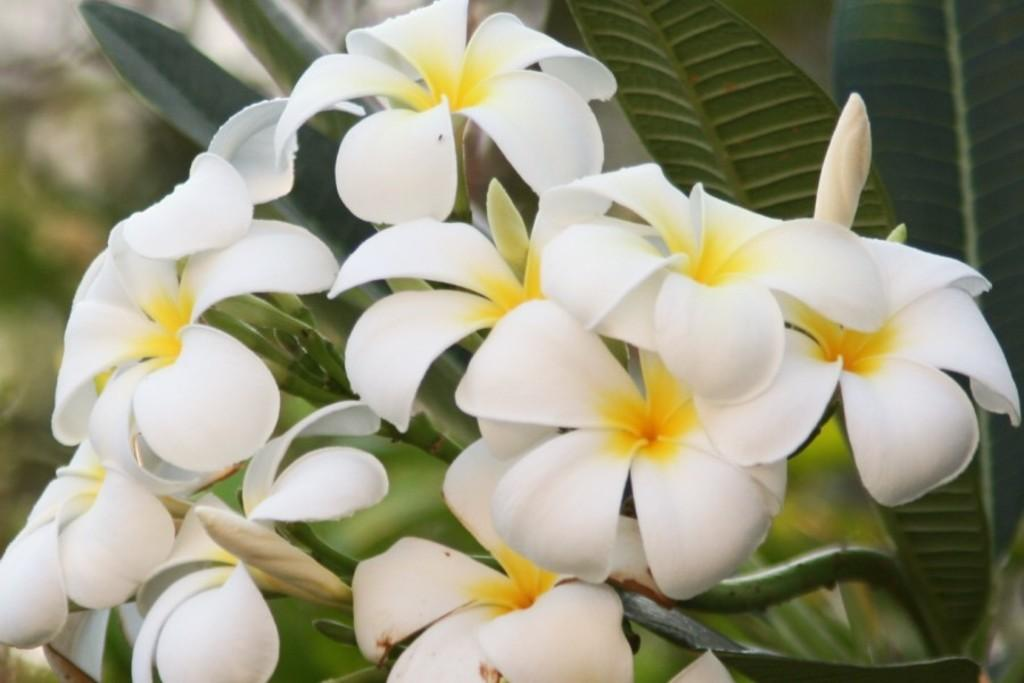What type of living organisms can be seen in the image? Plants can be seen in the image. What specific feature of the plants is visible? The plants have flowers. What color are the flowers? The flowers are white in color. What additional detail can be observed about the flowers? The flowers have a yellow part in the middle of the petals. What type of bun is being sold at the airport in the image? There is no bun or airport present in the image; it features plants with white flowers that have a yellow part in the middle of the petals. 